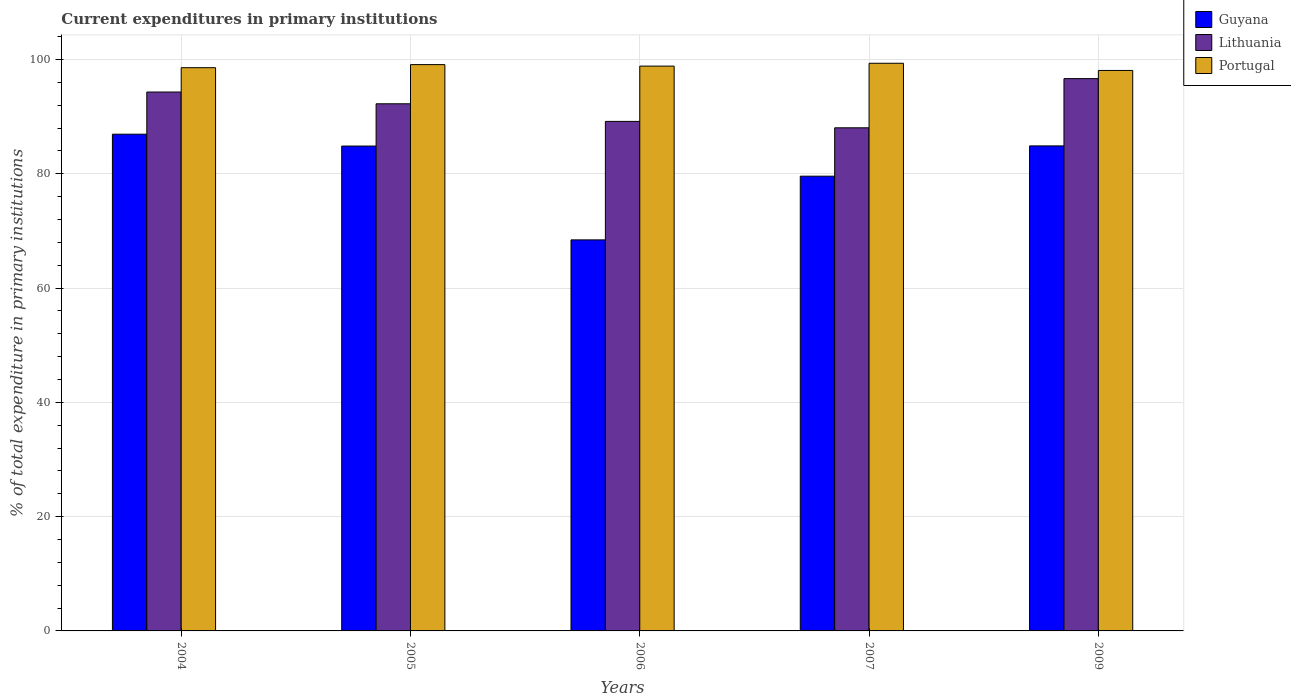How many different coloured bars are there?
Your response must be concise. 3. How many groups of bars are there?
Provide a short and direct response. 5. Are the number of bars on each tick of the X-axis equal?
Provide a short and direct response. Yes. How many bars are there on the 1st tick from the left?
Offer a terse response. 3. How many bars are there on the 4th tick from the right?
Provide a short and direct response. 3. What is the current expenditures in primary institutions in Guyana in 2004?
Your answer should be compact. 86.92. Across all years, what is the maximum current expenditures in primary institutions in Portugal?
Your response must be concise. 99.33. Across all years, what is the minimum current expenditures in primary institutions in Lithuania?
Give a very brief answer. 88.04. In which year was the current expenditures in primary institutions in Lithuania minimum?
Offer a very short reply. 2007. What is the total current expenditures in primary institutions in Guyana in the graph?
Your answer should be very brief. 404.63. What is the difference between the current expenditures in primary institutions in Portugal in 2005 and that in 2007?
Your answer should be very brief. -0.24. What is the difference between the current expenditures in primary institutions in Guyana in 2005 and the current expenditures in primary institutions in Portugal in 2006?
Your answer should be very brief. -13.99. What is the average current expenditures in primary institutions in Portugal per year?
Provide a short and direct response. 98.78. In the year 2005, what is the difference between the current expenditures in primary institutions in Portugal and current expenditures in primary institutions in Guyana?
Your answer should be very brief. 14.25. What is the ratio of the current expenditures in primary institutions in Portugal in 2004 to that in 2006?
Ensure brevity in your answer.  1. What is the difference between the highest and the second highest current expenditures in primary institutions in Portugal?
Offer a very short reply. 0.24. What is the difference between the highest and the lowest current expenditures in primary institutions in Portugal?
Keep it short and to the point. 1.26. In how many years, is the current expenditures in primary institutions in Lithuania greater than the average current expenditures in primary institutions in Lithuania taken over all years?
Ensure brevity in your answer.  3. What does the 1st bar from the left in 2007 represents?
Your answer should be compact. Guyana. Are all the bars in the graph horizontal?
Offer a very short reply. No. How many years are there in the graph?
Offer a very short reply. 5. Are the values on the major ticks of Y-axis written in scientific E-notation?
Offer a very short reply. No. Does the graph contain any zero values?
Offer a terse response. No. Does the graph contain grids?
Offer a very short reply. Yes. Where does the legend appear in the graph?
Offer a terse response. Top right. How are the legend labels stacked?
Provide a succinct answer. Vertical. What is the title of the graph?
Give a very brief answer. Current expenditures in primary institutions. Does "Georgia" appear as one of the legend labels in the graph?
Your answer should be very brief. No. What is the label or title of the X-axis?
Give a very brief answer. Years. What is the label or title of the Y-axis?
Offer a very short reply. % of total expenditure in primary institutions. What is the % of total expenditure in primary institutions of Guyana in 2004?
Offer a very short reply. 86.92. What is the % of total expenditure in primary institutions of Lithuania in 2004?
Give a very brief answer. 94.3. What is the % of total expenditure in primary institutions in Portugal in 2004?
Make the answer very short. 98.55. What is the % of total expenditure in primary institutions of Guyana in 2005?
Provide a succinct answer. 84.84. What is the % of total expenditure in primary institutions in Lithuania in 2005?
Provide a short and direct response. 92.24. What is the % of total expenditure in primary institutions in Portugal in 2005?
Give a very brief answer. 99.09. What is the % of total expenditure in primary institutions of Guyana in 2006?
Make the answer very short. 68.42. What is the % of total expenditure in primary institutions in Lithuania in 2006?
Ensure brevity in your answer.  89.16. What is the % of total expenditure in primary institutions of Portugal in 2006?
Offer a terse response. 98.83. What is the % of total expenditure in primary institutions of Guyana in 2007?
Make the answer very short. 79.57. What is the % of total expenditure in primary institutions in Lithuania in 2007?
Your answer should be very brief. 88.04. What is the % of total expenditure in primary institutions in Portugal in 2007?
Give a very brief answer. 99.33. What is the % of total expenditure in primary institutions of Guyana in 2009?
Make the answer very short. 84.87. What is the % of total expenditure in primary institutions of Lithuania in 2009?
Your response must be concise. 96.64. What is the % of total expenditure in primary institutions of Portugal in 2009?
Your answer should be compact. 98.07. Across all years, what is the maximum % of total expenditure in primary institutions in Guyana?
Ensure brevity in your answer.  86.92. Across all years, what is the maximum % of total expenditure in primary institutions of Lithuania?
Offer a terse response. 96.64. Across all years, what is the maximum % of total expenditure in primary institutions of Portugal?
Give a very brief answer. 99.33. Across all years, what is the minimum % of total expenditure in primary institutions of Guyana?
Your answer should be compact. 68.42. Across all years, what is the minimum % of total expenditure in primary institutions of Lithuania?
Your response must be concise. 88.04. Across all years, what is the minimum % of total expenditure in primary institutions in Portugal?
Provide a succinct answer. 98.07. What is the total % of total expenditure in primary institutions of Guyana in the graph?
Your response must be concise. 404.63. What is the total % of total expenditure in primary institutions in Lithuania in the graph?
Ensure brevity in your answer.  460.37. What is the total % of total expenditure in primary institutions in Portugal in the graph?
Offer a very short reply. 493.88. What is the difference between the % of total expenditure in primary institutions in Guyana in 2004 and that in 2005?
Your answer should be very brief. 2.08. What is the difference between the % of total expenditure in primary institutions of Lithuania in 2004 and that in 2005?
Offer a very short reply. 2.06. What is the difference between the % of total expenditure in primary institutions of Portugal in 2004 and that in 2005?
Ensure brevity in your answer.  -0.54. What is the difference between the % of total expenditure in primary institutions of Guyana in 2004 and that in 2006?
Offer a terse response. 18.49. What is the difference between the % of total expenditure in primary institutions of Lithuania in 2004 and that in 2006?
Ensure brevity in your answer.  5.14. What is the difference between the % of total expenditure in primary institutions of Portugal in 2004 and that in 2006?
Ensure brevity in your answer.  -0.28. What is the difference between the % of total expenditure in primary institutions of Guyana in 2004 and that in 2007?
Provide a short and direct response. 7.35. What is the difference between the % of total expenditure in primary institutions in Lithuania in 2004 and that in 2007?
Your answer should be very brief. 6.26. What is the difference between the % of total expenditure in primary institutions of Portugal in 2004 and that in 2007?
Offer a terse response. -0.78. What is the difference between the % of total expenditure in primary institutions in Guyana in 2004 and that in 2009?
Offer a very short reply. 2.05. What is the difference between the % of total expenditure in primary institutions in Lithuania in 2004 and that in 2009?
Ensure brevity in your answer.  -2.35. What is the difference between the % of total expenditure in primary institutions of Portugal in 2004 and that in 2009?
Provide a short and direct response. 0.48. What is the difference between the % of total expenditure in primary institutions in Guyana in 2005 and that in 2006?
Provide a short and direct response. 16.42. What is the difference between the % of total expenditure in primary institutions in Lithuania in 2005 and that in 2006?
Offer a very short reply. 3.08. What is the difference between the % of total expenditure in primary institutions in Portugal in 2005 and that in 2006?
Your answer should be compact. 0.26. What is the difference between the % of total expenditure in primary institutions of Guyana in 2005 and that in 2007?
Provide a succinct answer. 5.27. What is the difference between the % of total expenditure in primary institutions in Lithuania in 2005 and that in 2007?
Offer a terse response. 4.2. What is the difference between the % of total expenditure in primary institutions of Portugal in 2005 and that in 2007?
Offer a terse response. -0.24. What is the difference between the % of total expenditure in primary institutions in Guyana in 2005 and that in 2009?
Keep it short and to the point. -0.03. What is the difference between the % of total expenditure in primary institutions in Lithuania in 2005 and that in 2009?
Offer a very short reply. -4.4. What is the difference between the % of total expenditure in primary institutions in Portugal in 2005 and that in 2009?
Your answer should be compact. 1.02. What is the difference between the % of total expenditure in primary institutions of Guyana in 2006 and that in 2007?
Make the answer very short. -11.15. What is the difference between the % of total expenditure in primary institutions in Lithuania in 2006 and that in 2007?
Provide a succinct answer. 1.12. What is the difference between the % of total expenditure in primary institutions in Portugal in 2006 and that in 2007?
Keep it short and to the point. -0.5. What is the difference between the % of total expenditure in primary institutions in Guyana in 2006 and that in 2009?
Your answer should be compact. -16.45. What is the difference between the % of total expenditure in primary institutions of Lithuania in 2006 and that in 2009?
Give a very brief answer. -7.49. What is the difference between the % of total expenditure in primary institutions of Portugal in 2006 and that in 2009?
Keep it short and to the point. 0.76. What is the difference between the % of total expenditure in primary institutions of Guyana in 2007 and that in 2009?
Give a very brief answer. -5.3. What is the difference between the % of total expenditure in primary institutions in Lithuania in 2007 and that in 2009?
Give a very brief answer. -8.61. What is the difference between the % of total expenditure in primary institutions of Portugal in 2007 and that in 2009?
Give a very brief answer. 1.26. What is the difference between the % of total expenditure in primary institutions of Guyana in 2004 and the % of total expenditure in primary institutions of Lithuania in 2005?
Offer a very short reply. -5.32. What is the difference between the % of total expenditure in primary institutions of Guyana in 2004 and the % of total expenditure in primary institutions of Portugal in 2005?
Provide a short and direct response. -12.17. What is the difference between the % of total expenditure in primary institutions in Lithuania in 2004 and the % of total expenditure in primary institutions in Portugal in 2005?
Provide a short and direct response. -4.8. What is the difference between the % of total expenditure in primary institutions of Guyana in 2004 and the % of total expenditure in primary institutions of Lithuania in 2006?
Offer a terse response. -2.24. What is the difference between the % of total expenditure in primary institutions of Guyana in 2004 and the % of total expenditure in primary institutions of Portugal in 2006?
Make the answer very short. -11.91. What is the difference between the % of total expenditure in primary institutions in Lithuania in 2004 and the % of total expenditure in primary institutions in Portugal in 2006?
Provide a short and direct response. -4.54. What is the difference between the % of total expenditure in primary institutions of Guyana in 2004 and the % of total expenditure in primary institutions of Lithuania in 2007?
Keep it short and to the point. -1.12. What is the difference between the % of total expenditure in primary institutions of Guyana in 2004 and the % of total expenditure in primary institutions of Portugal in 2007?
Keep it short and to the point. -12.41. What is the difference between the % of total expenditure in primary institutions in Lithuania in 2004 and the % of total expenditure in primary institutions in Portugal in 2007?
Provide a succinct answer. -5.03. What is the difference between the % of total expenditure in primary institutions of Guyana in 2004 and the % of total expenditure in primary institutions of Lithuania in 2009?
Make the answer very short. -9.72. What is the difference between the % of total expenditure in primary institutions in Guyana in 2004 and the % of total expenditure in primary institutions in Portugal in 2009?
Ensure brevity in your answer.  -11.15. What is the difference between the % of total expenditure in primary institutions of Lithuania in 2004 and the % of total expenditure in primary institutions of Portugal in 2009?
Your answer should be very brief. -3.78. What is the difference between the % of total expenditure in primary institutions in Guyana in 2005 and the % of total expenditure in primary institutions in Lithuania in 2006?
Keep it short and to the point. -4.31. What is the difference between the % of total expenditure in primary institutions in Guyana in 2005 and the % of total expenditure in primary institutions in Portugal in 2006?
Your answer should be compact. -13.99. What is the difference between the % of total expenditure in primary institutions in Lithuania in 2005 and the % of total expenditure in primary institutions in Portugal in 2006?
Your response must be concise. -6.59. What is the difference between the % of total expenditure in primary institutions of Guyana in 2005 and the % of total expenditure in primary institutions of Lithuania in 2007?
Give a very brief answer. -3.19. What is the difference between the % of total expenditure in primary institutions of Guyana in 2005 and the % of total expenditure in primary institutions of Portugal in 2007?
Provide a succinct answer. -14.49. What is the difference between the % of total expenditure in primary institutions of Lithuania in 2005 and the % of total expenditure in primary institutions of Portugal in 2007?
Keep it short and to the point. -7.09. What is the difference between the % of total expenditure in primary institutions of Guyana in 2005 and the % of total expenditure in primary institutions of Lithuania in 2009?
Your answer should be compact. -11.8. What is the difference between the % of total expenditure in primary institutions in Guyana in 2005 and the % of total expenditure in primary institutions in Portugal in 2009?
Ensure brevity in your answer.  -13.23. What is the difference between the % of total expenditure in primary institutions of Lithuania in 2005 and the % of total expenditure in primary institutions of Portugal in 2009?
Your answer should be very brief. -5.83. What is the difference between the % of total expenditure in primary institutions in Guyana in 2006 and the % of total expenditure in primary institutions in Lithuania in 2007?
Offer a very short reply. -19.61. What is the difference between the % of total expenditure in primary institutions of Guyana in 2006 and the % of total expenditure in primary institutions of Portugal in 2007?
Make the answer very short. -30.91. What is the difference between the % of total expenditure in primary institutions in Lithuania in 2006 and the % of total expenditure in primary institutions in Portugal in 2007?
Provide a succinct answer. -10.17. What is the difference between the % of total expenditure in primary institutions in Guyana in 2006 and the % of total expenditure in primary institutions in Lithuania in 2009?
Your answer should be very brief. -28.22. What is the difference between the % of total expenditure in primary institutions in Guyana in 2006 and the % of total expenditure in primary institutions in Portugal in 2009?
Your response must be concise. -29.65. What is the difference between the % of total expenditure in primary institutions in Lithuania in 2006 and the % of total expenditure in primary institutions in Portugal in 2009?
Offer a very short reply. -8.92. What is the difference between the % of total expenditure in primary institutions in Guyana in 2007 and the % of total expenditure in primary institutions in Lithuania in 2009?
Provide a succinct answer. -17.07. What is the difference between the % of total expenditure in primary institutions in Guyana in 2007 and the % of total expenditure in primary institutions in Portugal in 2009?
Provide a succinct answer. -18.5. What is the difference between the % of total expenditure in primary institutions of Lithuania in 2007 and the % of total expenditure in primary institutions of Portugal in 2009?
Give a very brief answer. -10.04. What is the average % of total expenditure in primary institutions of Guyana per year?
Offer a terse response. 80.93. What is the average % of total expenditure in primary institutions in Lithuania per year?
Offer a terse response. 92.07. What is the average % of total expenditure in primary institutions in Portugal per year?
Keep it short and to the point. 98.78. In the year 2004, what is the difference between the % of total expenditure in primary institutions of Guyana and % of total expenditure in primary institutions of Lithuania?
Ensure brevity in your answer.  -7.38. In the year 2004, what is the difference between the % of total expenditure in primary institutions of Guyana and % of total expenditure in primary institutions of Portugal?
Give a very brief answer. -11.64. In the year 2004, what is the difference between the % of total expenditure in primary institutions of Lithuania and % of total expenditure in primary institutions of Portugal?
Your answer should be very brief. -4.26. In the year 2005, what is the difference between the % of total expenditure in primary institutions in Guyana and % of total expenditure in primary institutions in Lithuania?
Your answer should be compact. -7.4. In the year 2005, what is the difference between the % of total expenditure in primary institutions of Guyana and % of total expenditure in primary institutions of Portugal?
Keep it short and to the point. -14.25. In the year 2005, what is the difference between the % of total expenditure in primary institutions of Lithuania and % of total expenditure in primary institutions of Portugal?
Your answer should be very brief. -6.85. In the year 2006, what is the difference between the % of total expenditure in primary institutions of Guyana and % of total expenditure in primary institutions of Lithuania?
Give a very brief answer. -20.73. In the year 2006, what is the difference between the % of total expenditure in primary institutions in Guyana and % of total expenditure in primary institutions in Portugal?
Your response must be concise. -30.41. In the year 2006, what is the difference between the % of total expenditure in primary institutions in Lithuania and % of total expenditure in primary institutions in Portugal?
Give a very brief answer. -9.68. In the year 2007, what is the difference between the % of total expenditure in primary institutions of Guyana and % of total expenditure in primary institutions of Lithuania?
Offer a very short reply. -8.46. In the year 2007, what is the difference between the % of total expenditure in primary institutions of Guyana and % of total expenditure in primary institutions of Portugal?
Make the answer very short. -19.76. In the year 2007, what is the difference between the % of total expenditure in primary institutions in Lithuania and % of total expenditure in primary institutions in Portugal?
Provide a succinct answer. -11.29. In the year 2009, what is the difference between the % of total expenditure in primary institutions in Guyana and % of total expenditure in primary institutions in Lithuania?
Your answer should be very brief. -11.77. In the year 2009, what is the difference between the % of total expenditure in primary institutions of Guyana and % of total expenditure in primary institutions of Portugal?
Keep it short and to the point. -13.2. In the year 2009, what is the difference between the % of total expenditure in primary institutions in Lithuania and % of total expenditure in primary institutions in Portugal?
Offer a terse response. -1.43. What is the ratio of the % of total expenditure in primary institutions of Guyana in 2004 to that in 2005?
Offer a very short reply. 1.02. What is the ratio of the % of total expenditure in primary institutions of Lithuania in 2004 to that in 2005?
Your answer should be very brief. 1.02. What is the ratio of the % of total expenditure in primary institutions in Portugal in 2004 to that in 2005?
Your answer should be very brief. 0.99. What is the ratio of the % of total expenditure in primary institutions of Guyana in 2004 to that in 2006?
Offer a very short reply. 1.27. What is the ratio of the % of total expenditure in primary institutions of Lithuania in 2004 to that in 2006?
Give a very brief answer. 1.06. What is the ratio of the % of total expenditure in primary institutions of Guyana in 2004 to that in 2007?
Provide a short and direct response. 1.09. What is the ratio of the % of total expenditure in primary institutions in Lithuania in 2004 to that in 2007?
Your response must be concise. 1.07. What is the ratio of the % of total expenditure in primary institutions of Portugal in 2004 to that in 2007?
Your response must be concise. 0.99. What is the ratio of the % of total expenditure in primary institutions of Guyana in 2004 to that in 2009?
Make the answer very short. 1.02. What is the ratio of the % of total expenditure in primary institutions in Lithuania in 2004 to that in 2009?
Your answer should be compact. 0.98. What is the ratio of the % of total expenditure in primary institutions in Guyana in 2005 to that in 2006?
Offer a terse response. 1.24. What is the ratio of the % of total expenditure in primary institutions in Lithuania in 2005 to that in 2006?
Make the answer very short. 1.03. What is the ratio of the % of total expenditure in primary institutions of Guyana in 2005 to that in 2007?
Your answer should be very brief. 1.07. What is the ratio of the % of total expenditure in primary institutions of Lithuania in 2005 to that in 2007?
Your response must be concise. 1.05. What is the ratio of the % of total expenditure in primary institutions of Guyana in 2005 to that in 2009?
Keep it short and to the point. 1. What is the ratio of the % of total expenditure in primary institutions in Lithuania in 2005 to that in 2009?
Offer a terse response. 0.95. What is the ratio of the % of total expenditure in primary institutions of Portugal in 2005 to that in 2009?
Your answer should be very brief. 1.01. What is the ratio of the % of total expenditure in primary institutions in Guyana in 2006 to that in 2007?
Keep it short and to the point. 0.86. What is the ratio of the % of total expenditure in primary institutions in Lithuania in 2006 to that in 2007?
Your answer should be compact. 1.01. What is the ratio of the % of total expenditure in primary institutions in Guyana in 2006 to that in 2009?
Offer a terse response. 0.81. What is the ratio of the % of total expenditure in primary institutions in Lithuania in 2006 to that in 2009?
Provide a succinct answer. 0.92. What is the ratio of the % of total expenditure in primary institutions of Guyana in 2007 to that in 2009?
Offer a terse response. 0.94. What is the ratio of the % of total expenditure in primary institutions of Lithuania in 2007 to that in 2009?
Your answer should be compact. 0.91. What is the ratio of the % of total expenditure in primary institutions in Portugal in 2007 to that in 2009?
Ensure brevity in your answer.  1.01. What is the difference between the highest and the second highest % of total expenditure in primary institutions of Guyana?
Make the answer very short. 2.05. What is the difference between the highest and the second highest % of total expenditure in primary institutions in Lithuania?
Make the answer very short. 2.35. What is the difference between the highest and the second highest % of total expenditure in primary institutions in Portugal?
Offer a very short reply. 0.24. What is the difference between the highest and the lowest % of total expenditure in primary institutions in Guyana?
Keep it short and to the point. 18.49. What is the difference between the highest and the lowest % of total expenditure in primary institutions of Lithuania?
Provide a short and direct response. 8.61. What is the difference between the highest and the lowest % of total expenditure in primary institutions of Portugal?
Offer a very short reply. 1.26. 